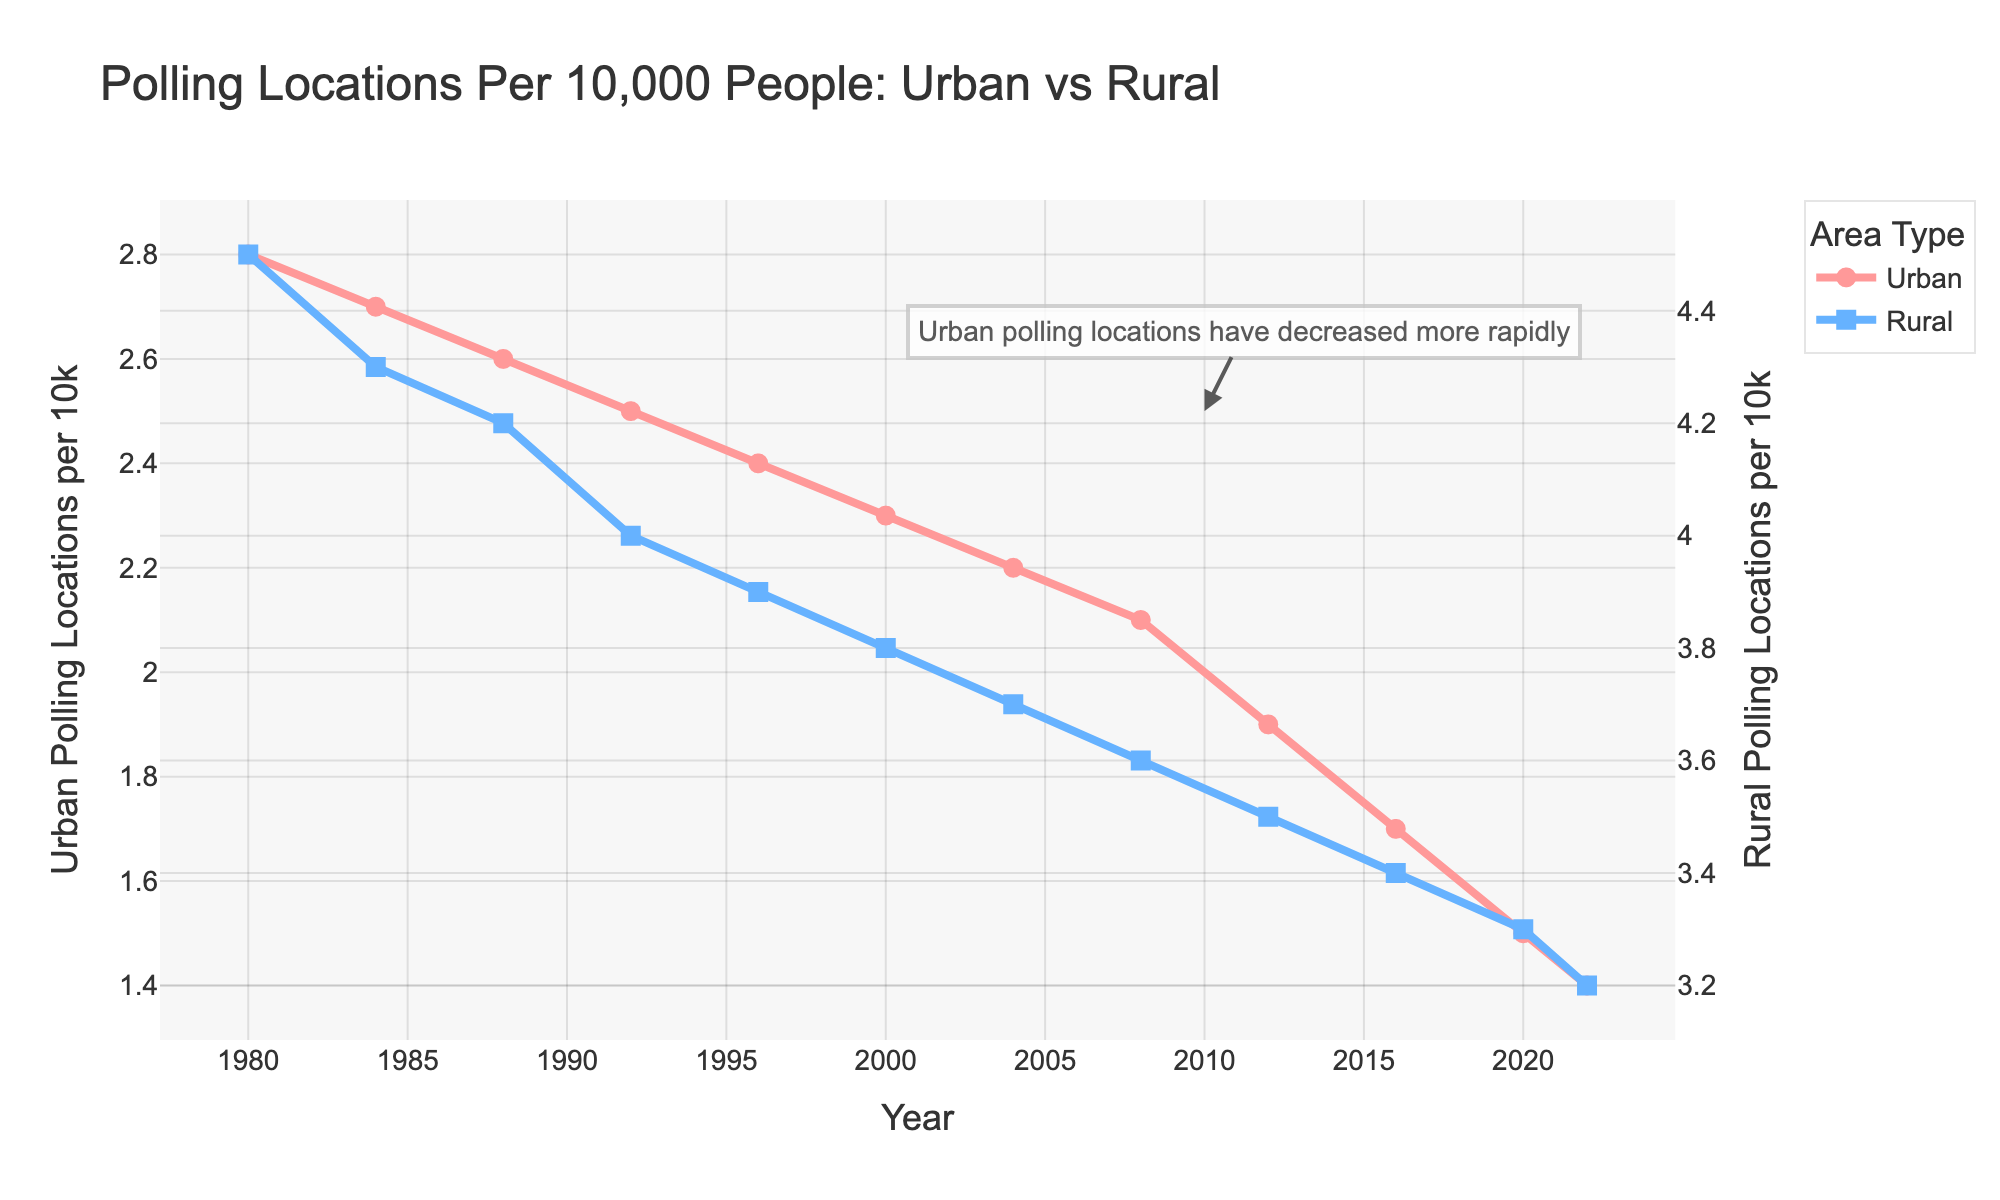What trends do you observe in the number of urban and rural polling locations per capita from 1980 to 2022? Looking at the overall trend for urban polling locations, there is a consistent decrease from 2.8 per 10,000 people in 1980 to 1.4 per 10,000 people in 2022. For rural areas, there is also a downward trend but not as steep, decreasing from 4.5 per 10,000 people in 1980 to 3.2 per 10,000 people in 2022.
Answer: Downward trend for both, steeper for urban areas Which year marks a significant difference in the rate of decline between urban and rural polling locations per capita? A more noticeable difference in the rate of decline starts around 2012. Before this year, the slopes are relatively similar, but post-2012, urban polling locations continue to decline more sharply compared to rural ones.
Answer: 2012 How much did the number of polling locations per 10,000 in rural areas decrease from 1980 to 2022? In rural areas, the number of polling locations decreased from 4.5 per 10,000 people in 1980 to 3.2 per 10,000 people in 2022. The decrease is 4.5 - 3.2 = 1.3.
Answer: 1.3 Which type of area had a higher number of polling locations per capita throughout the time period shown? Throughout the entire period from 1980 to 2022, rural areas consistently had a higher number of polling locations per 10,000 people compared to urban areas.
Answer: Rural areas What is the percentage decrease in the number of urban polling locations per capita from 1980 to 2022? The number of urban polling locations per capita in 1980 was 2.8 per 10,000 people, and in 2022 it was 1.4 per 10,000 people. The percentage decrease is calculated as ((2.8 - 1.4) / 2.8) * 100 = 50%.
Answer: 50% In which year did urban polling locations per capita drop below 2 per 10,000 people? Looking at the data trend, urban polling locations per capita dropped below 2 per 10,000 people in the year 2012.
Answer: 2012 How does the rate of decline in rural polling locations per capita compare to the rate of decline in urban polling locations per capita from 1980 to 2022? The decline rate is steeper in urban areas compared to rural areas. Urban polling locations per capita decreased from 2.8 to 1.4, which is a 50% decrease. Rural polling locations decreased from 4.5 to 3.2, which is roughly a 28.9% decrease.
Answer: Steeper in urban areas What is the difference in the number of polling locations per 10,000 people between urban and rural areas in 2022? In 2022, the number of urban polling locations per 10,000 people was 1.4, and in rural areas, it was 3.2. The difference is 3.2 - 1.4 = 1.8.
Answer: 1.8 Identify the years when both urban and rural polling locations per capita were closest in value. The values for urban and rural polling locations per capita were closest in 2022, with 1.4 for urban and 3.2 for rural, marking the smallest numerical gap throughout the timeline presented.
Answer: 2022 